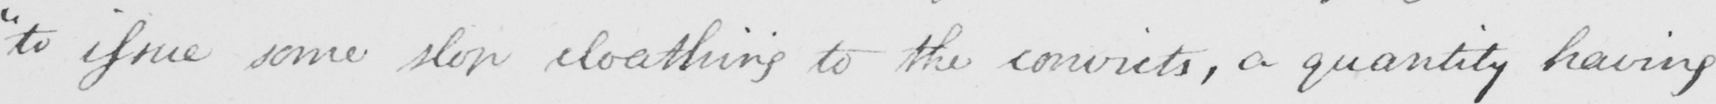What is written in this line of handwriting? " to issue some slop cloathing to the convicts , a quantity having 